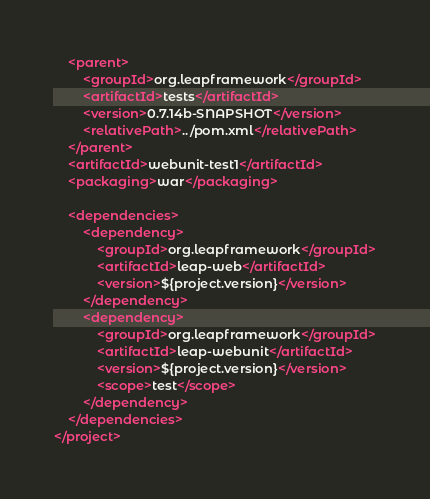Convert code to text. <code><loc_0><loc_0><loc_500><loc_500><_XML_>	<parent>
		<groupId>org.leapframework</groupId>
		<artifactId>tests</artifactId>
		<version>0.7.14b-SNAPSHOT</version>
		<relativePath>../pom.xml</relativePath>
	</parent>
	<artifactId>webunit-test1</artifactId>
	<packaging>war</packaging>

	<dependencies>
		<dependency>
			<groupId>org.leapframework</groupId>
			<artifactId>leap-web</artifactId>
			<version>${project.version}</version>
		</dependency>
		<dependency>
			<groupId>org.leapframework</groupId>
			<artifactId>leap-webunit</artifactId>
			<version>${project.version}</version>
			<scope>test</scope>
		</dependency>
	</dependencies>
</project>
</code> 